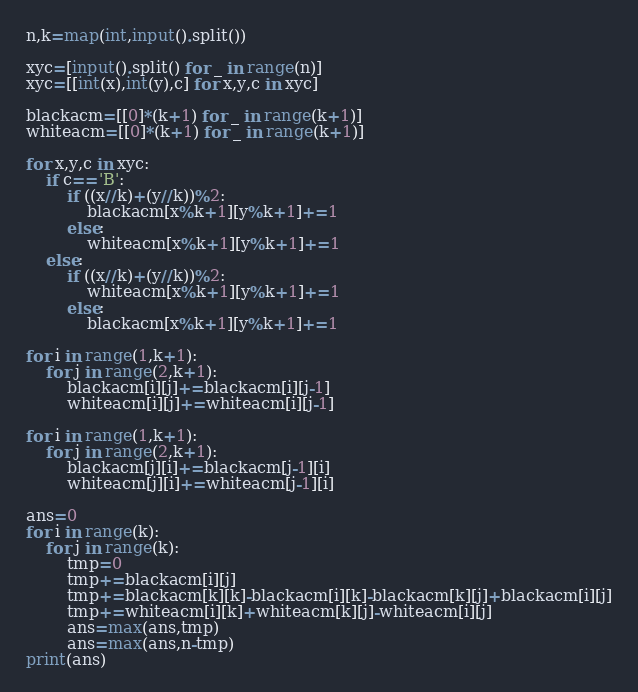<code> <loc_0><loc_0><loc_500><loc_500><_Python_>n,k=map(int,input().split())

xyc=[input().split() for _ in range(n)]
xyc=[[int(x),int(y),c] for x,y,c in xyc]

blackacm=[[0]*(k+1) for _ in range(k+1)]
whiteacm=[[0]*(k+1) for _ in range(k+1)]

for x,y,c in xyc:
    if c=='B':
        if ((x//k)+(y//k))%2:
            blackacm[x%k+1][y%k+1]+=1
        else:
            whiteacm[x%k+1][y%k+1]+=1
    else:
        if ((x//k)+(y//k))%2:
            whiteacm[x%k+1][y%k+1]+=1
        else:
            blackacm[x%k+1][y%k+1]+=1

for i in range(1,k+1):
    for j in range(2,k+1):
        blackacm[i][j]+=blackacm[i][j-1]
        whiteacm[i][j]+=whiteacm[i][j-1]

for i in range(1,k+1):
    for j in range(2,k+1):
        blackacm[j][i]+=blackacm[j-1][i]
        whiteacm[j][i]+=whiteacm[j-1][i]

ans=0
for i in range(k):
    for j in range(k):
        tmp=0
        tmp+=blackacm[i][j]
        tmp+=blackacm[k][k]-blackacm[i][k]-blackacm[k][j]+blackacm[i][j]
        tmp+=whiteacm[i][k]+whiteacm[k][j]-whiteacm[i][j]
        ans=max(ans,tmp)
        ans=max(ans,n-tmp)
print(ans)</code> 